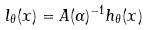Convert formula to latex. <formula><loc_0><loc_0><loc_500><loc_500>l _ { \theta } ( x ) = A ( \alpha ) ^ { - 1 } h _ { \theta } ( x )</formula> 